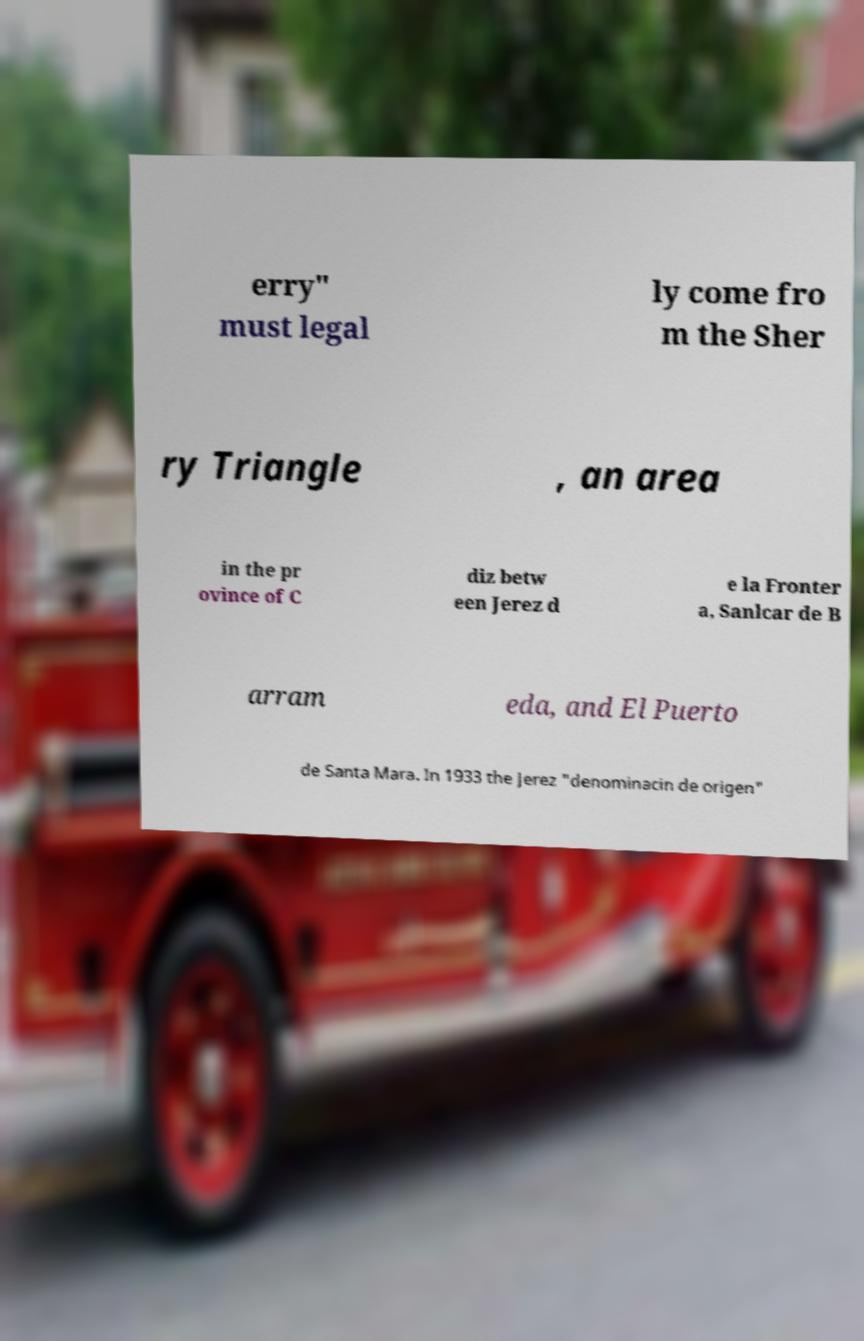Please read and relay the text visible in this image. What does it say? erry" must legal ly come fro m the Sher ry Triangle , an area in the pr ovince of C diz betw een Jerez d e la Fronter a, Sanlcar de B arram eda, and El Puerto de Santa Mara. In 1933 the Jerez "denominacin de origen" 